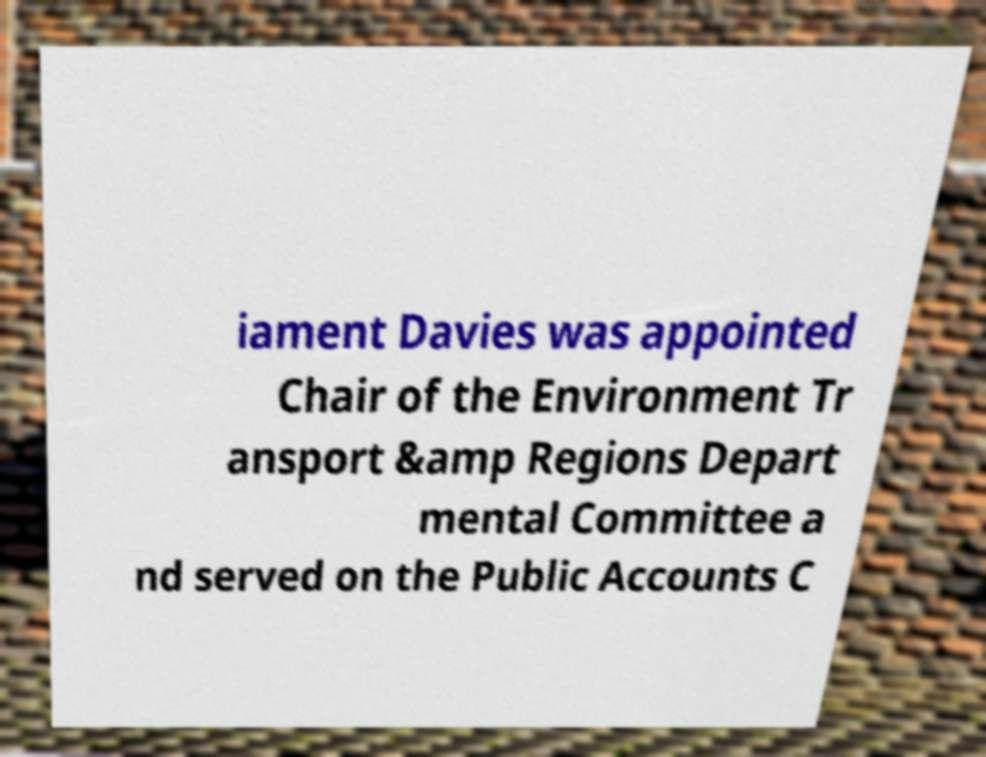I need the written content from this picture converted into text. Can you do that? iament Davies was appointed Chair of the Environment Tr ansport &amp Regions Depart mental Committee a nd served on the Public Accounts C 